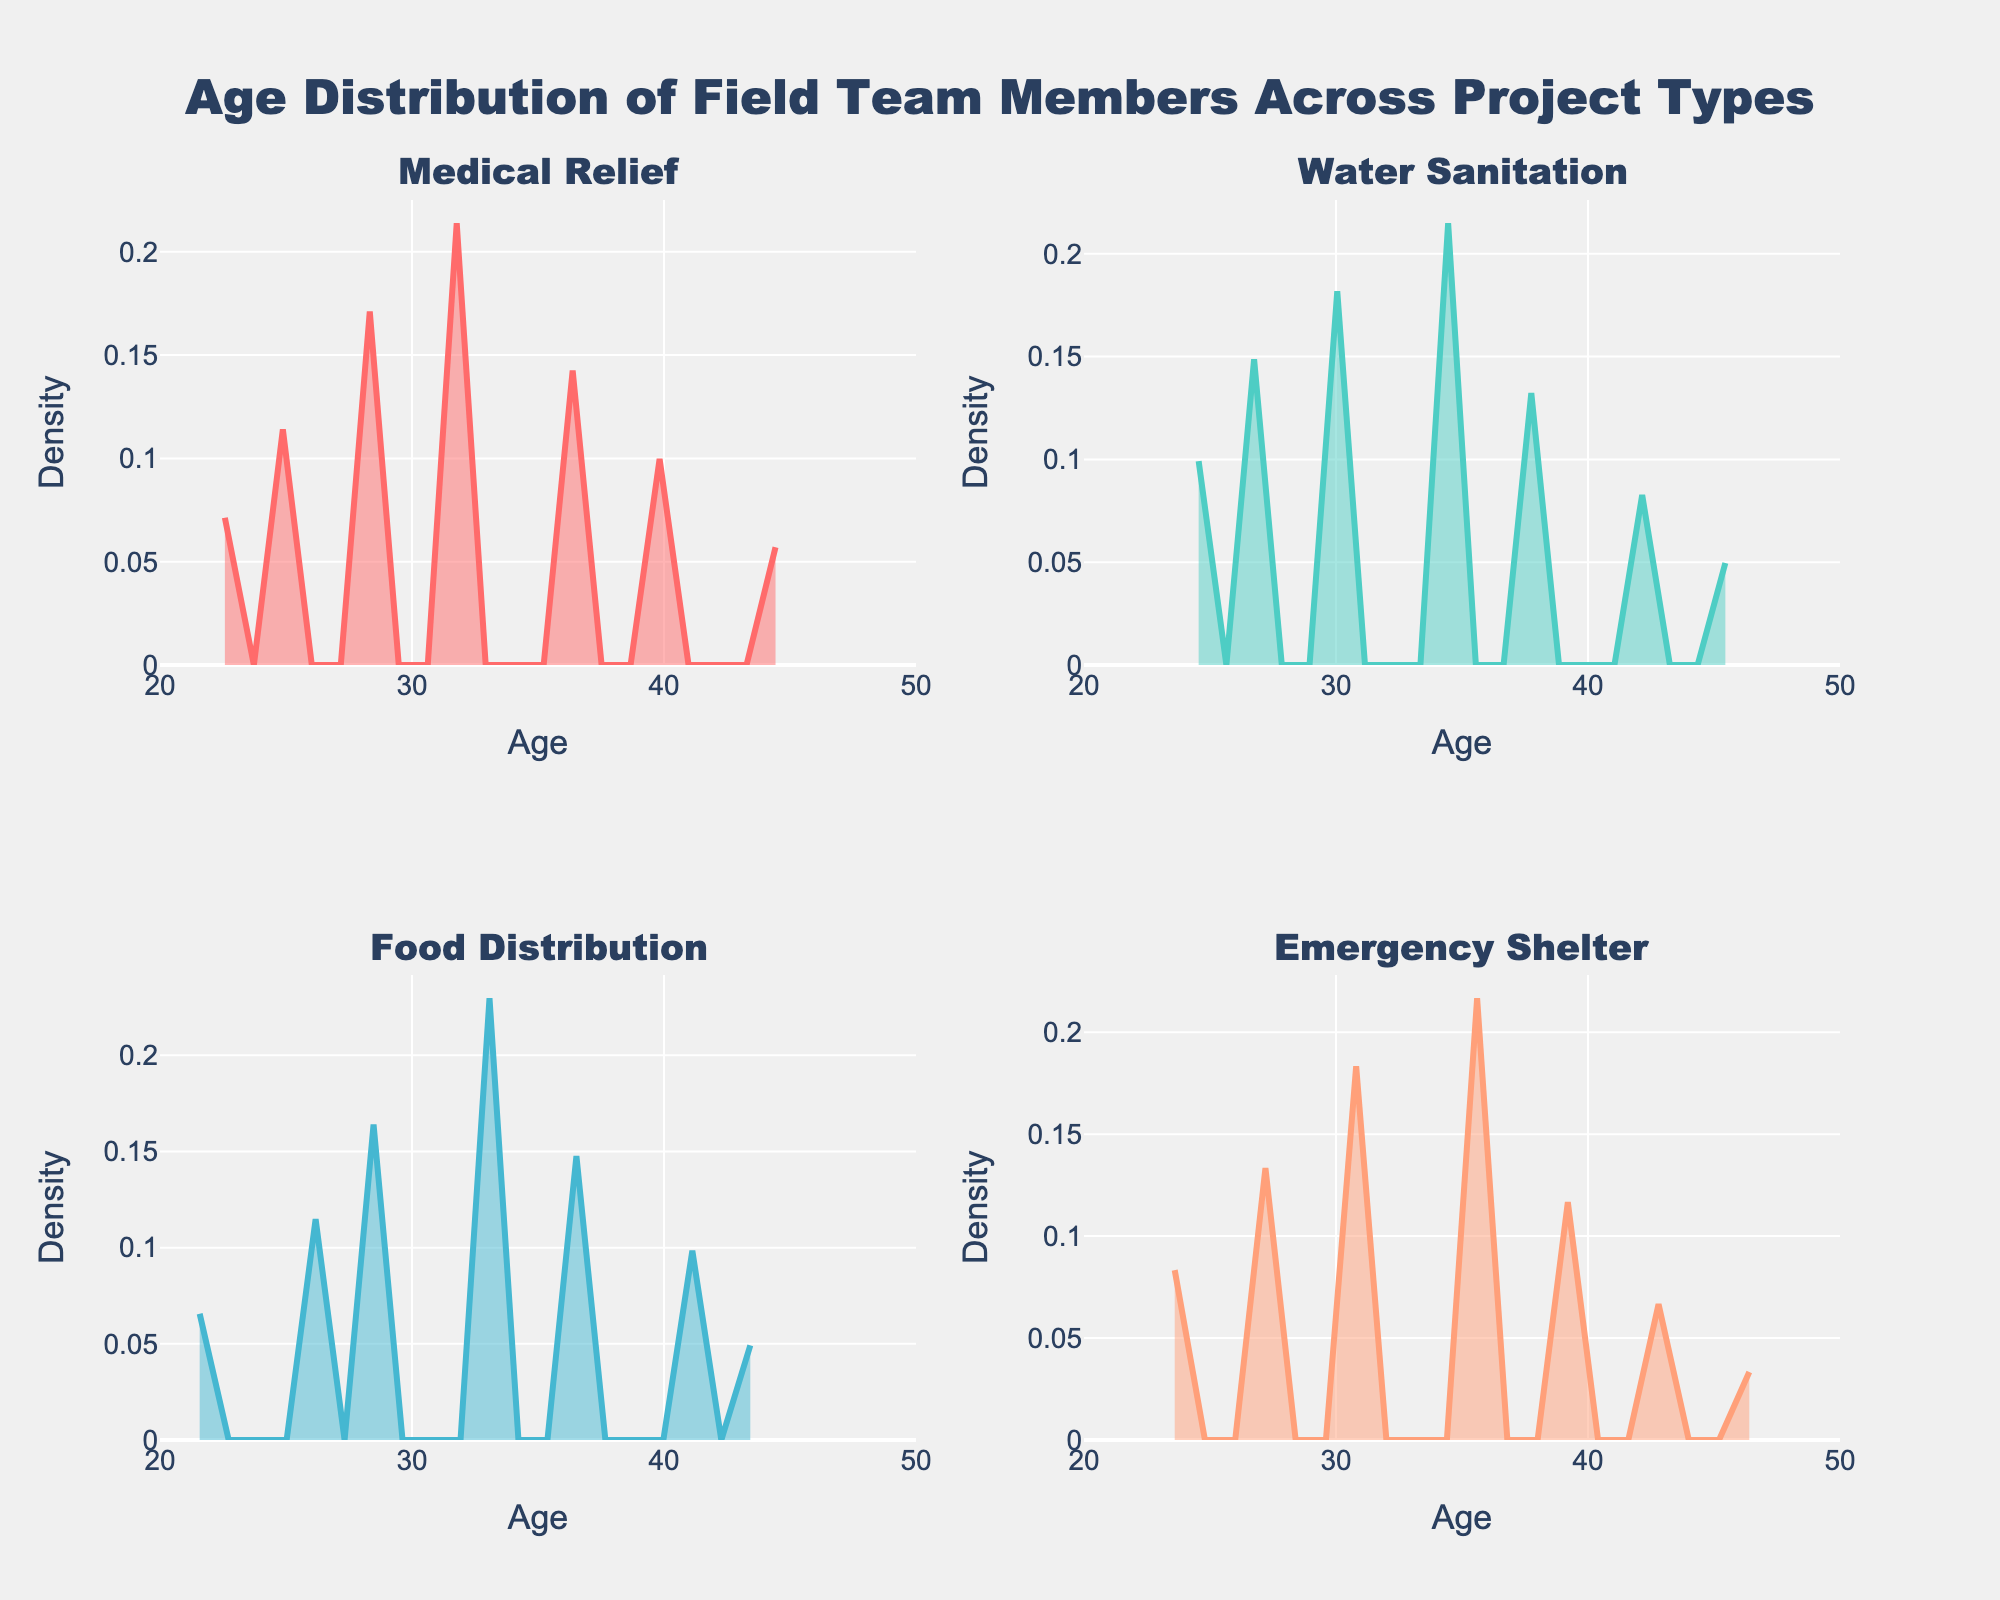What is the title of the figure? The title of the figure is displayed at the top center. It reads, "Age Distribution of Field Team Members Across Project Types".
Answer: Age Distribution of Field Team Members Across Project Types Which project type has the highest peak in the density plot? The Emergency Shelter project type shows the highest peak in its density plot, indicating the most common age, around 35, has the greatest density among all project types.
Answer: Emergency Shelter What ages have the highest density in the Medical Relief project type? By examining the density plot for Medical Relief, the ages around 32 have the highest density, indicating a significant number of field team members at this age.
Answer: 32 How do the peaks of the density plots for Water Sanitation and Food Distribution compare? The Water Sanitation density plot peaks around age 34, whereas the Food Distribution peaks around age 33. The peak for Water Sanitation is slightly higher than Food Distribution, indicating a more pronounced age clustering.
Answer: Water Sanitation's peak is higher and at age 34; Food Distribution's peak is at age 33 Which project type exhibits the broadest age distribution? The Emergency Shelter project type has the broadest age distribution, as indicated by its wider spread and more gradual density decline on both sides of the peak.
Answer: Emergency Shelter What is the age range covered by the density plot for Medical Relief? The plot for Medical Relief shows densities spanning from age 22 to age 45. These mark the boundaries indicating where the age distribution starts and ends for this project type.
Answer: 22 to 45 Which two adjacent project types show the least overlap in their age distributions? By comparing the density plots, it's evident that Medical Relief and Water Sanitation show the least overlap, with distinct peaks and minimal shared density regions.
Answer: Medical Relief and Water Sanitation What's the difference in peak density values between Water Sanitation and Emergency Shelter? The peak for Water Sanitation has a lower density than Emergency Shelter. To determine the difference, measure the highest points of each plot; Emergency Shelter around 35 is denser than Water Sanitation around 34.
Answer: Emergency Shelter's peak density is higher by a slight margin 